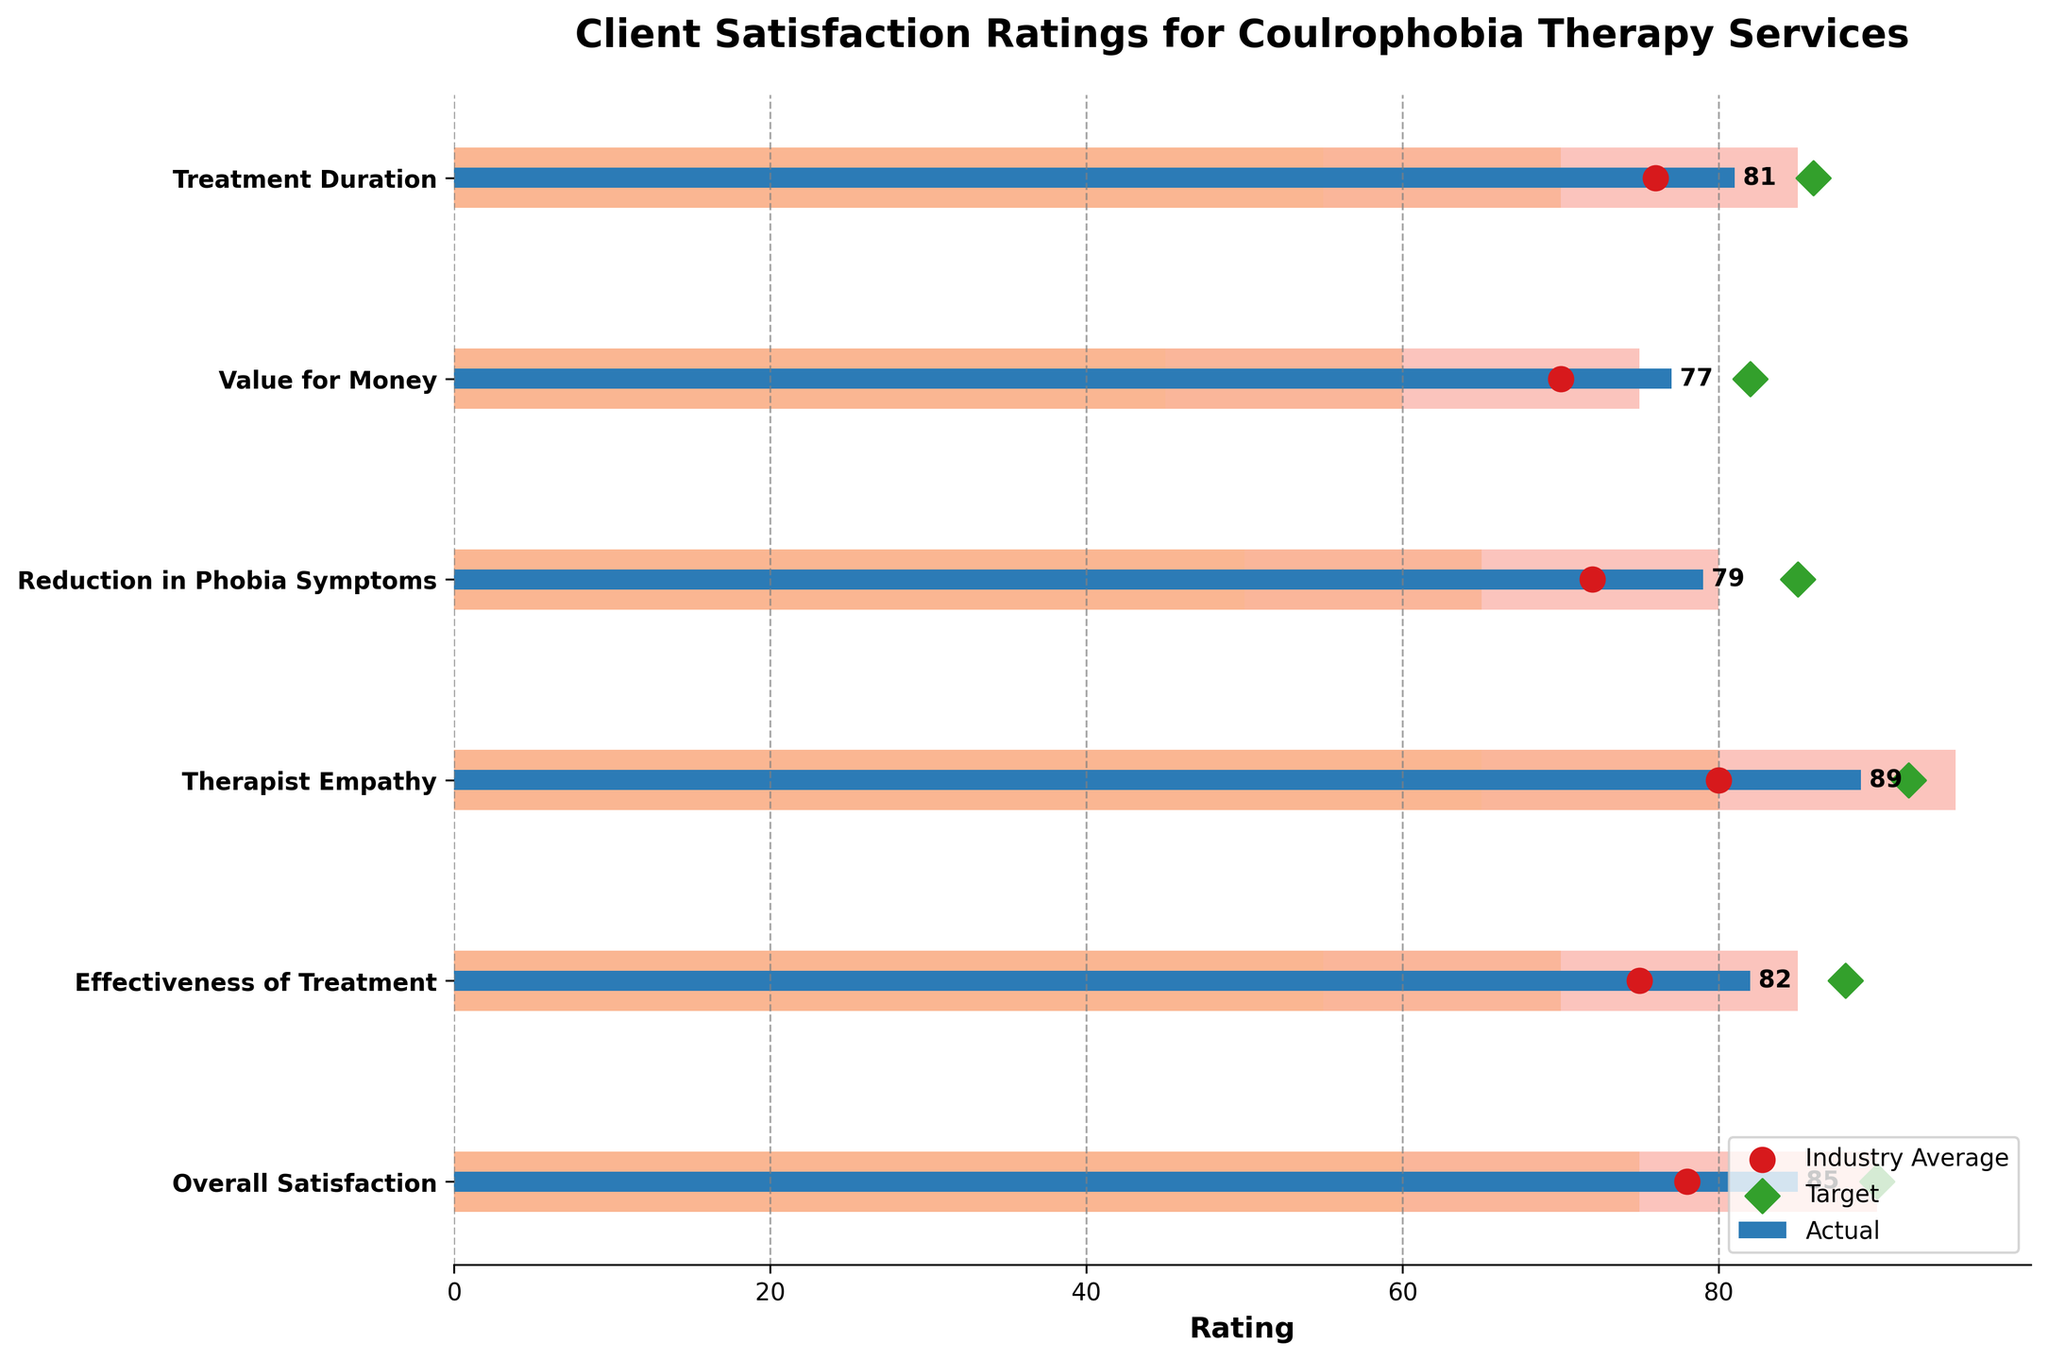What is the title of the chart? The title of the chart is found at the top and it's displayed in bold.
Answer: Client Satisfaction Ratings for Coulrophobia Therapy Services Which category has the lowest actual satisfaction rating? By looking at the length of the blue bars, the shortest one corresponds to "Value for Money".
Answer: Value for Money Which category's actual rating is closest to its target? Compare the blue bar (actual rating) with the green diamond markers (target) for each category. The "Therapist Empathy" category has an actual rating of 89 and a target of 92, which is the closest.
Answer: Therapist Empathy How does the overall satisfaction rating compare to the industry average? Look at the position of the blue bar (actual) and the red circle (industry average) for "Overall Satisfaction". The actual rating is 85, while the industry average is 78.
Answer: Higher How many categories have an actual rating above their comparative industry average? Count the blue bars that extend beyond the red circles. There are six categories in total, and all of them have actual ratings above the industry averages.
Answer: Six What is the range of the "Effectiveness of Treatment" category? Refer to the colored background sections (ranges) behind the bars for the "Effectiveness of Treatment". It shows that the range is from 55 to 85.
Answer: 55 to 85 Which category has the largest difference between actual and target ratings? Calculate the difference between the blue bar (actual) and the green diamond (target) for each category. The "Reduction in Phobia Symptoms" has a target of 85 and an actual of 79, thus a difference of 6, which is the largest.
Answer: Reduction in Phobia Symptoms Is there any category where the actual rating is equal to the target rating? Compare the position of the blue bar (actual) to the green diamond marker (target) for each category. None of the categories show equal values.
Answer: No Which satisfaction rating category is just above the mid-range of its quotas? For each category, identify where the actual (blue bar) value falls within the colored background (ranges). "Therapist Empathy" with an actual rating of 89 is just above the mid-range (between 65 and 95).
Answer: Therapist Empathy What is the difference between the actual and industry average ratings for "Treatment Duration"? Subtract the industry average (red circle) from the actual rating (blue bar) for "Treatment Duration". The actual rating is 81 and the industry average is 76, so the difference is 5.
Answer: 5 